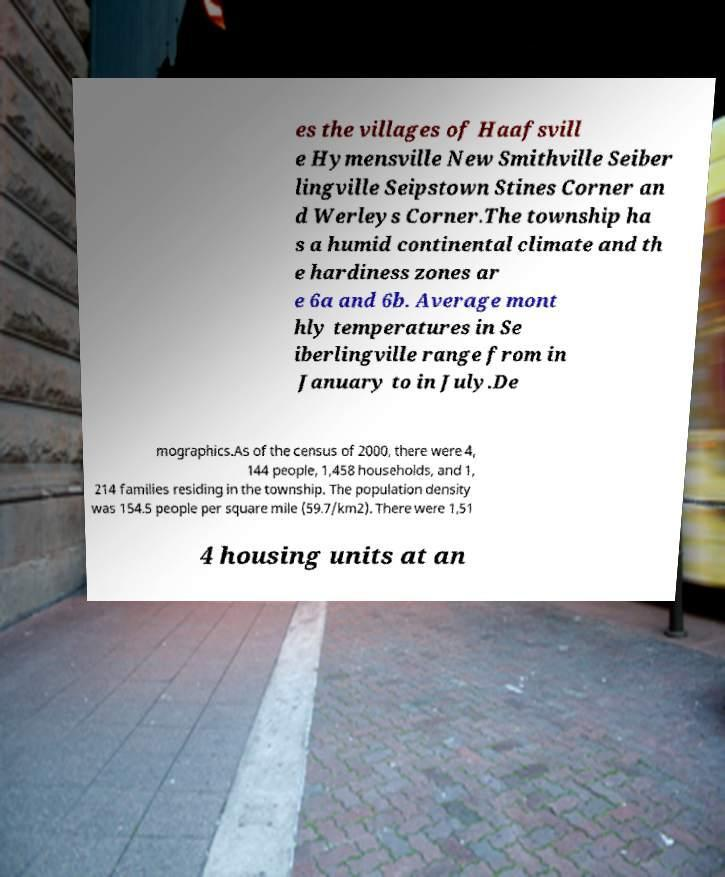Could you extract and type out the text from this image? es the villages of Haafsvill e Hymensville New Smithville Seiber lingville Seipstown Stines Corner an d Werleys Corner.The township ha s a humid continental climate and th e hardiness zones ar e 6a and 6b. Average mont hly temperatures in Se iberlingville range from in January to in July.De mographics.As of the census of 2000, there were 4, 144 people, 1,458 households, and 1, 214 families residing in the township. The population density was 154.5 people per square mile (59.7/km2). There were 1,51 4 housing units at an 